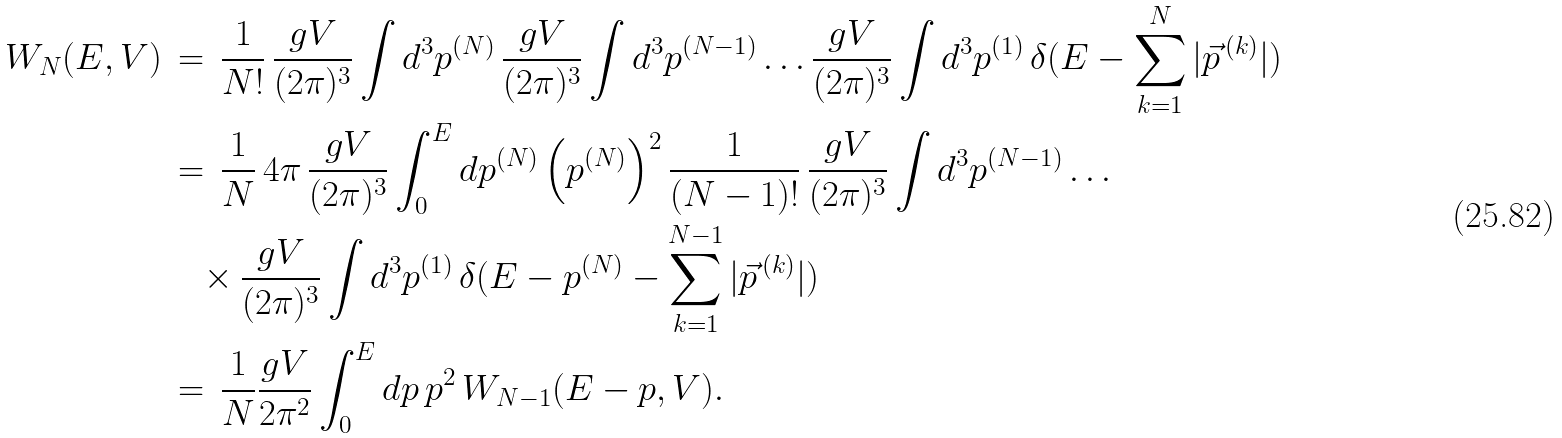Convert formula to latex. <formula><loc_0><loc_0><loc_500><loc_500>W _ { N } ( E , V ) & \, = \, \frac { 1 } { N ! } \, \frac { g V } { ( 2 \pi ) ^ { 3 } } \int d ^ { 3 } p ^ { ( N ) } \, \frac { g V } { ( 2 \pi ) ^ { 3 } } \int d ^ { 3 } p ^ { ( N - 1 ) } \dots \frac { g V } { ( 2 \pi ) ^ { 3 } } \int d ^ { 3 } p ^ { ( 1 ) } \, \delta ( E - \sum _ { k = 1 } ^ { N } | \vec { p } ^ { \, ( k ) } | ) \\ & \, = \, \frac { 1 } { N } \, 4 \pi \, \frac { g V } { ( 2 \pi ) ^ { 3 } } \int _ { 0 } ^ { E } d p ^ { ( N ) } \left ( p ^ { ( N ) } \right ) ^ { 2 } \frac { 1 } { ( N - 1 ) ! } \, \frac { g V } { ( 2 \pi ) ^ { 3 } } \int d ^ { 3 } p ^ { ( N - 1 ) } \dots \\ & \quad \times \frac { g V } { ( 2 \pi ) ^ { 3 } } \int d ^ { 3 } p ^ { ( 1 ) } \, \delta ( E - p ^ { ( N ) } - \sum _ { k = 1 } ^ { N - 1 } | \vec { p } ^ { \, ( k ) } | ) \\ & \, = \, \frac { 1 } { N } \frac { g V } { 2 \pi ^ { 2 } } \int _ { 0 } ^ { E } d p \, p ^ { 2 } \, W _ { N - 1 } ( E - p , V ) .</formula> 